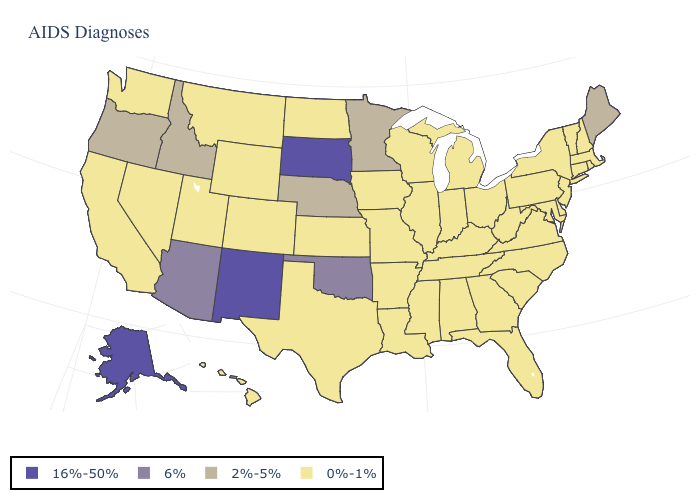What is the value of Vermont?
Answer briefly. 0%-1%. Name the states that have a value in the range 0%-1%?
Write a very short answer. Alabama, Arkansas, California, Colorado, Connecticut, Delaware, Florida, Georgia, Hawaii, Illinois, Indiana, Iowa, Kansas, Kentucky, Louisiana, Maryland, Massachusetts, Michigan, Mississippi, Missouri, Montana, Nevada, New Hampshire, New Jersey, New York, North Carolina, North Dakota, Ohio, Pennsylvania, Rhode Island, South Carolina, Tennessee, Texas, Utah, Vermont, Virginia, Washington, West Virginia, Wisconsin, Wyoming. Name the states that have a value in the range 0%-1%?
Quick response, please. Alabama, Arkansas, California, Colorado, Connecticut, Delaware, Florida, Georgia, Hawaii, Illinois, Indiana, Iowa, Kansas, Kentucky, Louisiana, Maryland, Massachusetts, Michigan, Mississippi, Missouri, Montana, Nevada, New Hampshire, New Jersey, New York, North Carolina, North Dakota, Ohio, Pennsylvania, Rhode Island, South Carolina, Tennessee, Texas, Utah, Vermont, Virginia, Washington, West Virginia, Wisconsin, Wyoming. What is the highest value in the USA?
Concise answer only. 16%-50%. What is the value of Missouri?
Write a very short answer. 0%-1%. What is the value of Illinois?
Keep it brief. 0%-1%. Name the states that have a value in the range 16%-50%?
Give a very brief answer. Alaska, New Mexico, South Dakota. Name the states that have a value in the range 16%-50%?
Be succinct. Alaska, New Mexico, South Dakota. Which states have the highest value in the USA?
Write a very short answer. Alaska, New Mexico, South Dakota. What is the value of Alabama?
Quick response, please. 0%-1%. What is the highest value in the South ?
Give a very brief answer. 6%. Does Nebraska have the lowest value in the MidWest?
Concise answer only. No. Name the states that have a value in the range 6%?
Answer briefly. Arizona, Oklahoma. Which states have the highest value in the USA?
Keep it brief. Alaska, New Mexico, South Dakota. 